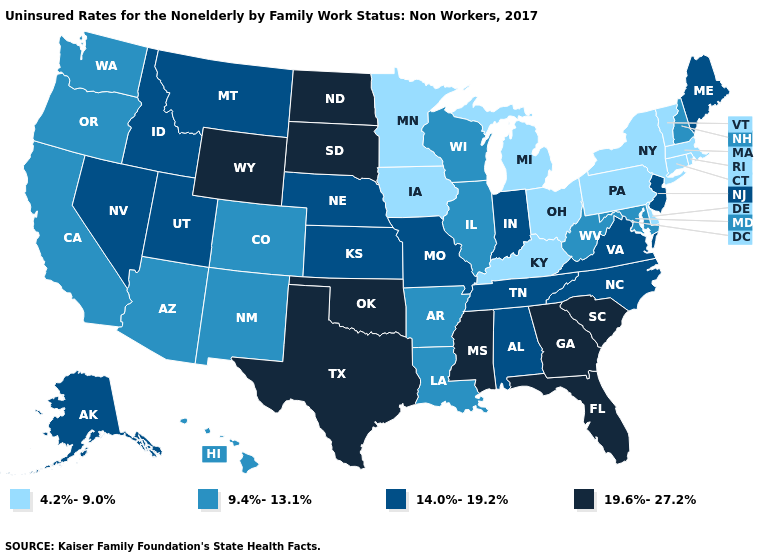Among the states that border Ohio , which have the lowest value?
Short answer required. Kentucky, Michigan, Pennsylvania. Name the states that have a value in the range 19.6%-27.2%?
Be succinct. Florida, Georgia, Mississippi, North Dakota, Oklahoma, South Carolina, South Dakota, Texas, Wyoming. Among the states that border Florida , does Georgia have the lowest value?
Quick response, please. No. Is the legend a continuous bar?
Be succinct. No. Among the states that border Nevada , does Idaho have the highest value?
Write a very short answer. Yes. Name the states that have a value in the range 9.4%-13.1%?
Write a very short answer. Arizona, Arkansas, California, Colorado, Hawaii, Illinois, Louisiana, Maryland, New Hampshire, New Mexico, Oregon, Washington, West Virginia, Wisconsin. Which states have the lowest value in the USA?
Be succinct. Connecticut, Delaware, Iowa, Kentucky, Massachusetts, Michigan, Minnesota, New York, Ohio, Pennsylvania, Rhode Island, Vermont. Name the states that have a value in the range 19.6%-27.2%?
Quick response, please. Florida, Georgia, Mississippi, North Dakota, Oklahoma, South Carolina, South Dakota, Texas, Wyoming. Does North Dakota have the highest value in the USA?
Quick response, please. Yes. What is the lowest value in the Northeast?
Give a very brief answer. 4.2%-9.0%. How many symbols are there in the legend?
Quick response, please. 4. What is the value of Illinois?
Keep it brief. 9.4%-13.1%. How many symbols are there in the legend?
Keep it brief. 4. What is the lowest value in states that border Louisiana?
Keep it brief. 9.4%-13.1%. What is the value of Oklahoma?
Write a very short answer. 19.6%-27.2%. 